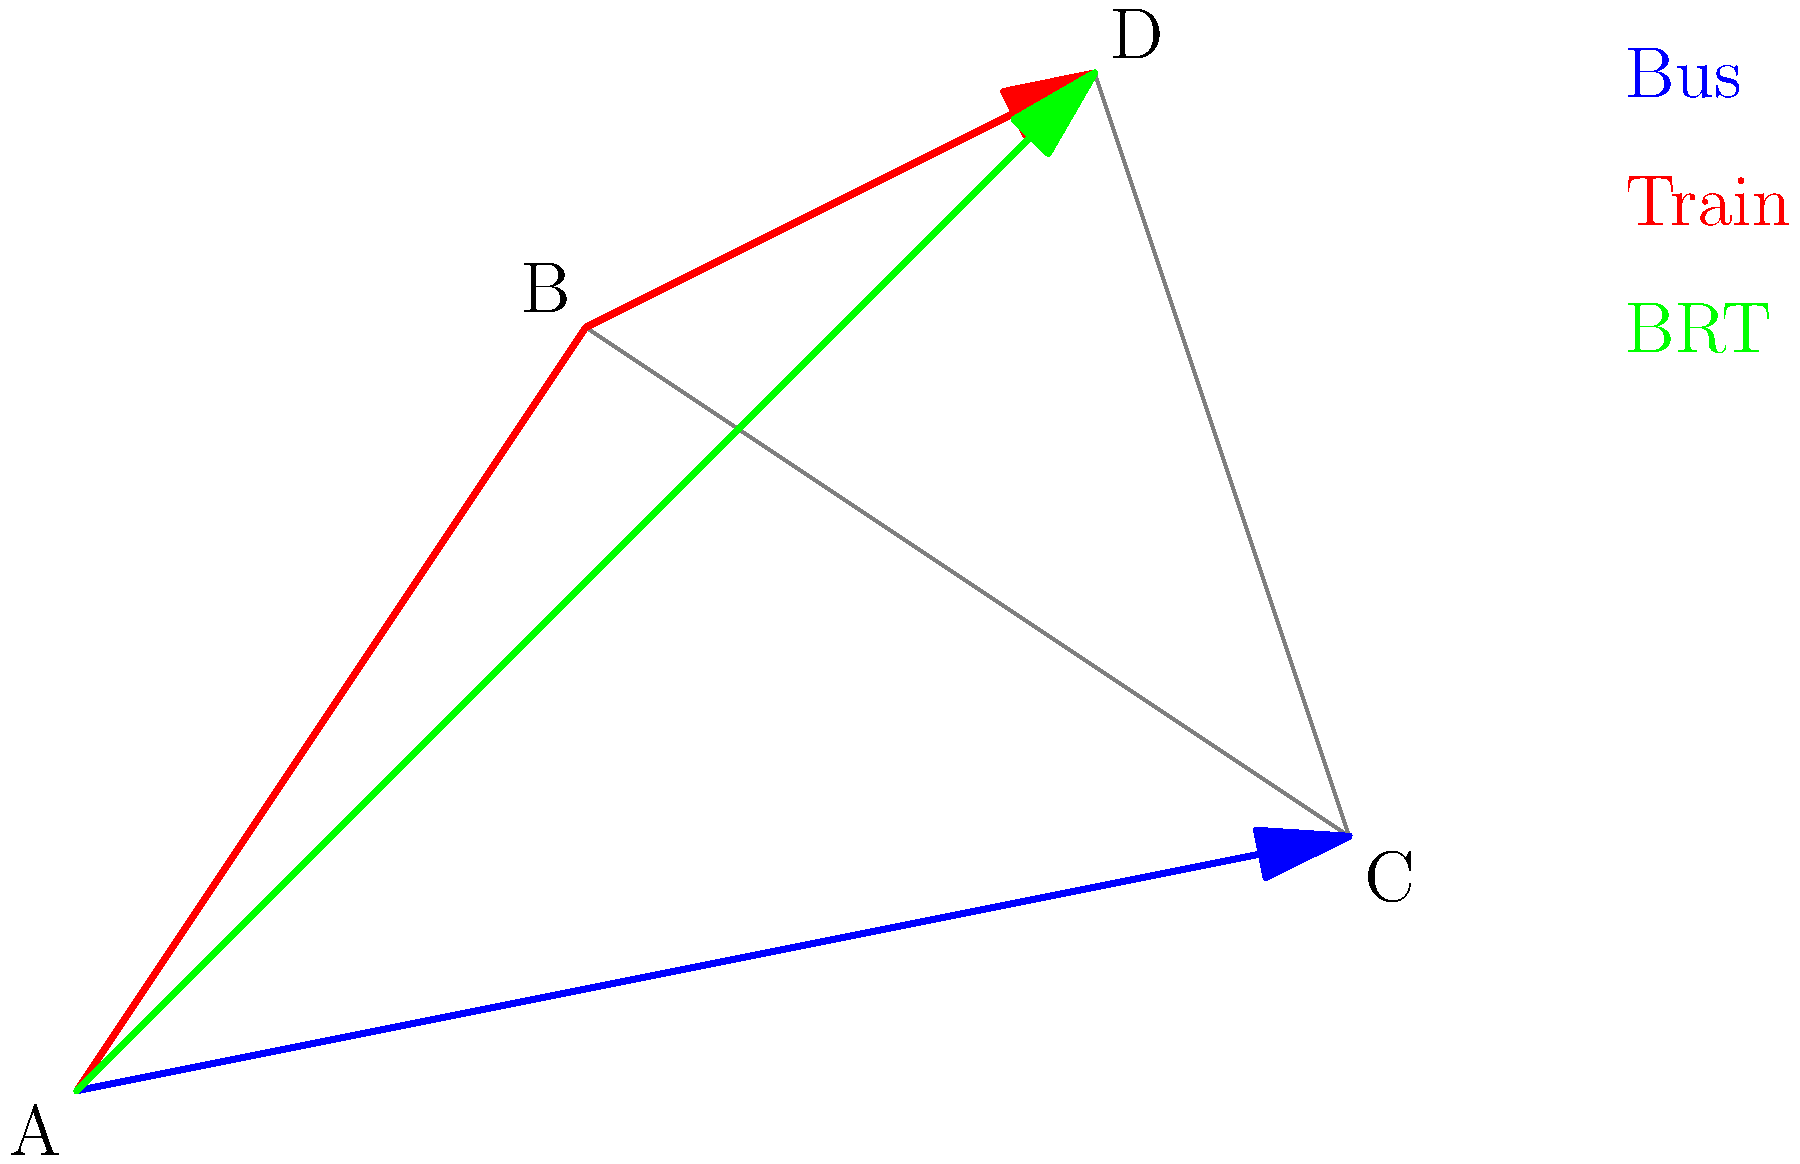Given the Lagos city map above showing different public transportation routes between locations A, B, C, and D, which route would be the most efficient to travel from point A to point D considering time and cost? To determine the most efficient route from point A to point D, we need to consider the following factors:

1. Distance: The direct route is often the shortest and potentially fastest.
2. Mode of transportation: Different modes have varying speeds and costs.
3. Number of stops: Fewer stops usually mean faster travel times.

Let's analyze each route:

1. Blue route (Bus): A to C to D
   - Involves two segments
   - Buses are generally slower and make frequent stops
   - Longer distance compared to other options

2. Red route (Train): A to B to D
   - Involves two segments
   - Trains are typically faster than buses and have fewer stops
   - Distance is shorter than the bus route

3. Green route (BRT - Bus Rapid Transit): A to D
   - Direct route with no intermediate stops
   - BRT systems are designed for speed and efficiency
   - Shortest distance among all options

Considering these factors:
- The BRT (green route) offers the most direct path with no stops
- BRT systems in Lagos are known for their dedicated lanes, reducing traffic delays
- It combines the speed of rail with the flexibility of buses
- The cost is typically lower than trains and comparable to regular buses

Therefore, the BRT route (green) from A directly to D would be the most efficient in terms of both time and cost.
Answer: BRT (green route) 